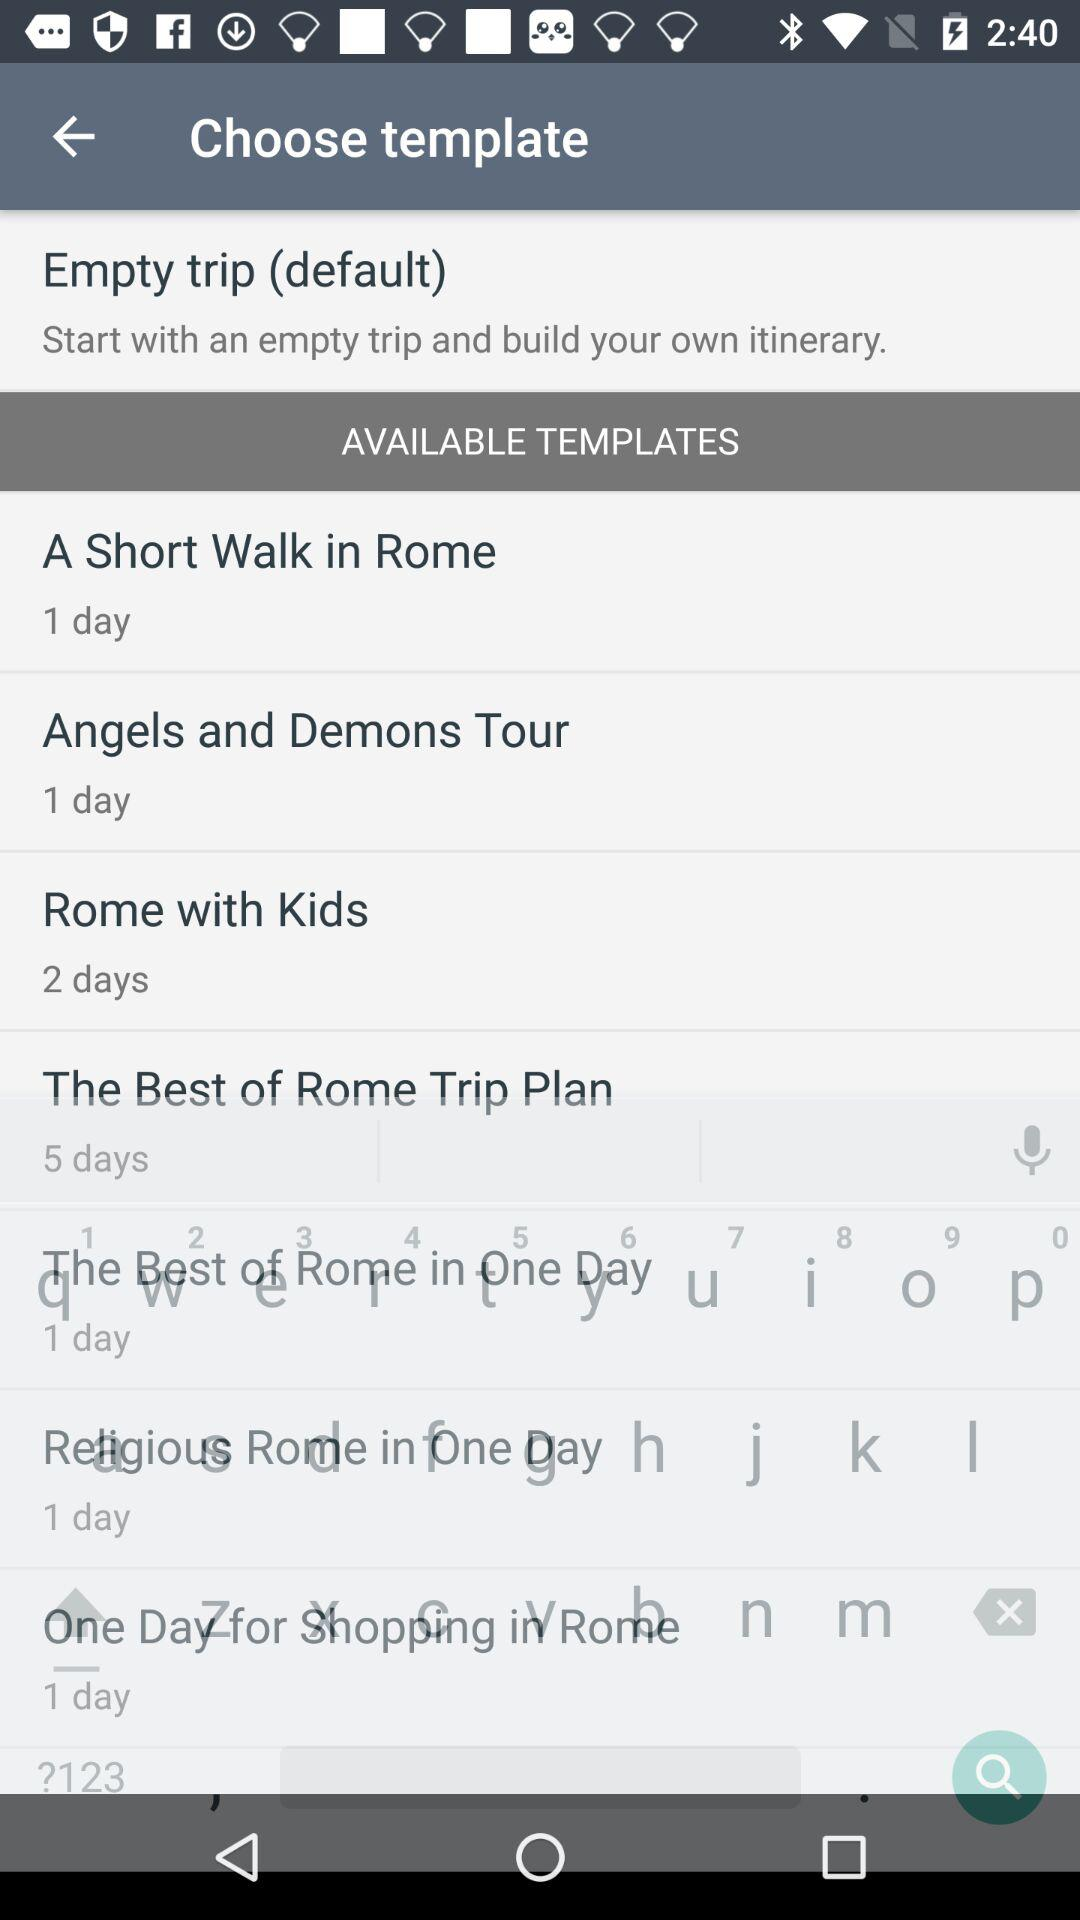For how many days is the "Rome with Kids" template available? It is available for 2 days. 